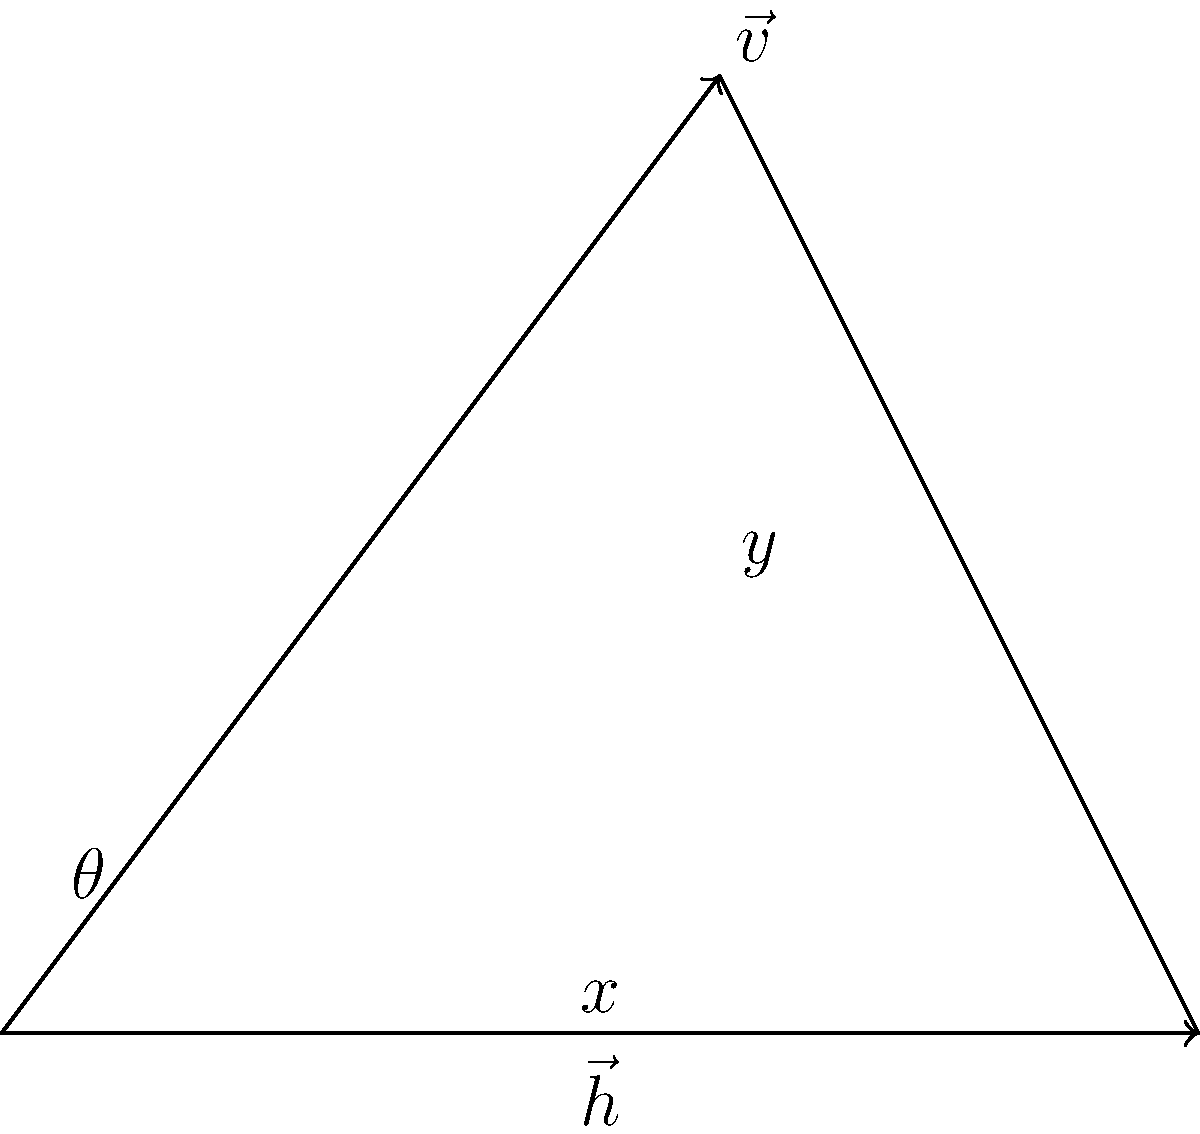In analyzing your swing mechanics, a sports scientist breaks down your bat speed vector into horizontal and vertical components. If your bat speed vector $\vec{v}$ has a magnitude of 100 mph and makes an angle of $53.13°$ with the horizontal, what is the magnitude of the horizontal component $\vec{h}$ of your swing? To solve this problem, we'll use the concept of vector components and trigonometry. Here's a step-by-step approach:

1) The horizontal component of a vector is related to its magnitude and angle by the cosine function.

2) Given:
   - Bat speed vector magnitude: $|\vec{v}| = 100$ mph
   - Angle with horizontal: $\theta = 53.13°$

3) The formula for the horizontal component is:
   $|\vec{h}| = |\vec{v}| \cos(\theta)$

4) Substituting the values:
   $|\vec{h}| = 100 \cdot \cos(53.13°)$

5) Using a calculator or trigonometric tables:
   $\cos(53.13°) \approx 0.6$

6) Therefore:
   $|\vec{h}| = 100 \cdot 0.6 = 60$ mph

Thus, the magnitude of the horizontal component of your swing is 60 mph.
Answer: 60 mph 